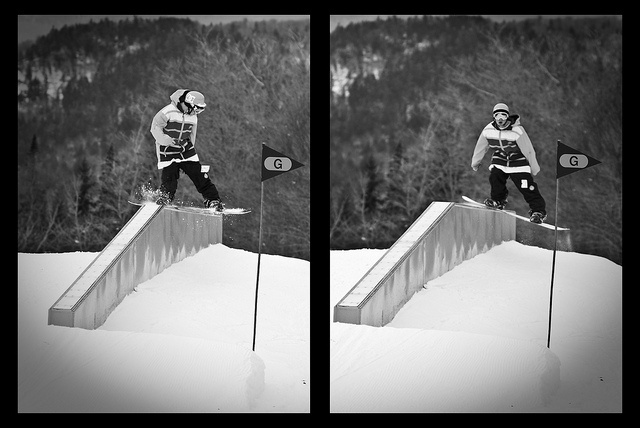Describe the objects in this image and their specific colors. I can see people in black, gray, lightgray, and darkgray tones, people in black, gray, darkgray, and gainsboro tones, snowboard in black, gray, lightgray, and darkgray tones, and snowboard in black, lightgray, gray, and darkgray tones in this image. 